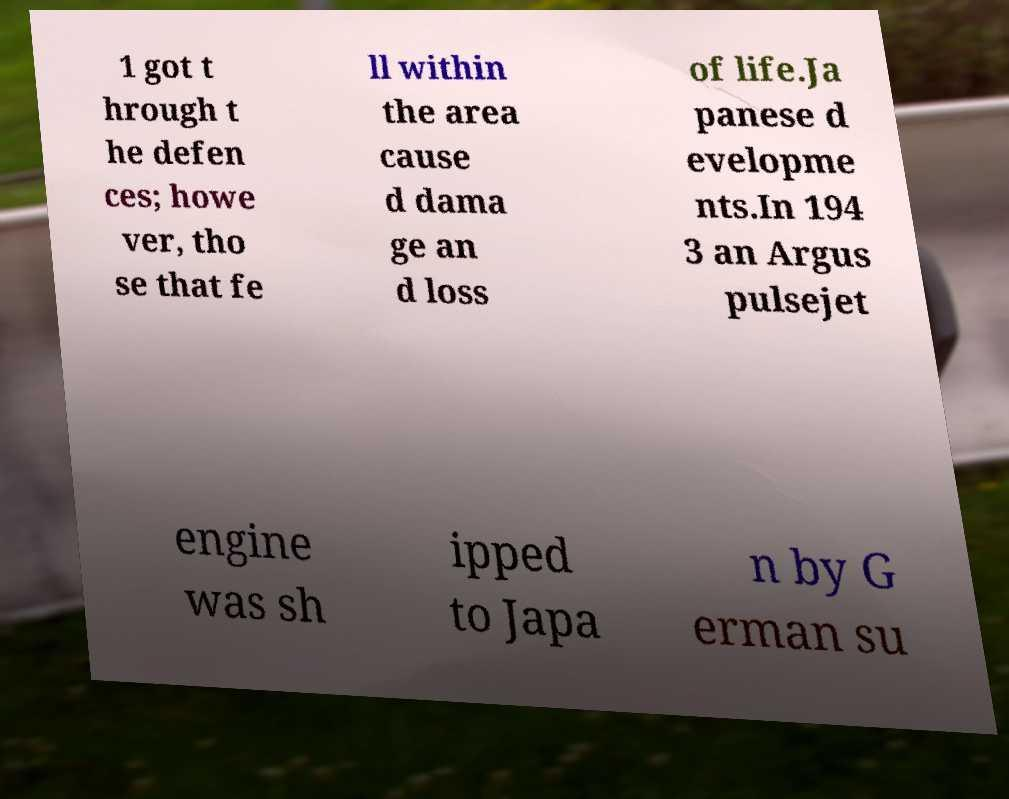Could you extract and type out the text from this image? 1 got t hrough t he defen ces; howe ver, tho se that fe ll within the area cause d dama ge an d loss of life.Ja panese d evelopme nts.In 194 3 an Argus pulsejet engine was sh ipped to Japa n by G erman su 